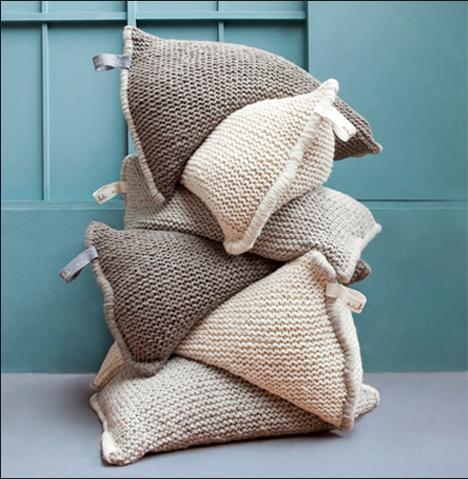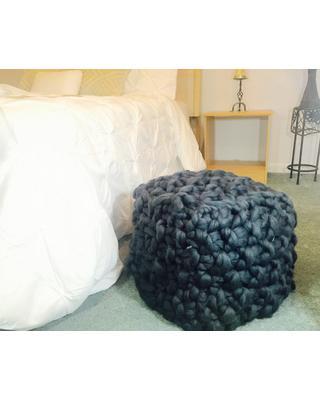The first image is the image on the left, the second image is the image on the right. Evaluate the accuracy of this statement regarding the images: "Each image contains a squarish knit pillow made of chunky yarn, and at least one image features such a pillow in a cream color.". Is it true? Answer yes or no. No. The first image is the image on the left, the second image is the image on the right. Analyze the images presented: Is the assertion "There are at least 3 crochet pillow stacked on top of each other." valid? Answer yes or no. Yes. 